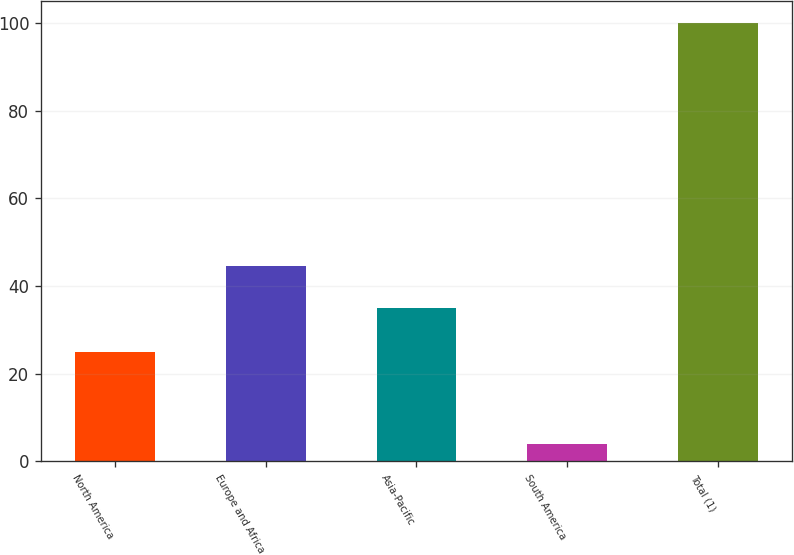Convert chart. <chart><loc_0><loc_0><loc_500><loc_500><bar_chart><fcel>North America<fcel>Europe and Africa<fcel>Asia-Pacific<fcel>South America<fcel>Total (1)<nl><fcel>25<fcel>44.6<fcel>35<fcel>4<fcel>100<nl></chart> 